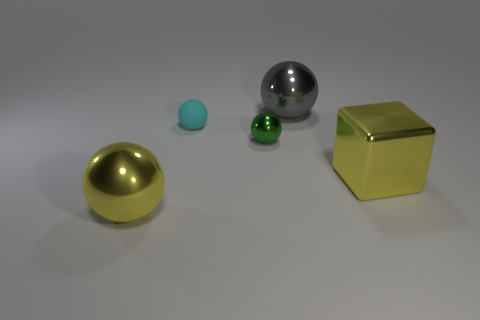Subtract all brown balls. Subtract all red cubes. How many balls are left? 4 Add 3 big gray rubber cylinders. How many objects exist? 8 Subtract all cubes. How many objects are left? 4 Add 2 yellow shiny balls. How many yellow shiny balls are left? 3 Add 3 small cyan rubber balls. How many small cyan rubber balls exist? 4 Subtract 0 purple spheres. How many objects are left? 5 Subtract all gray metallic spheres. Subtract all yellow shiny blocks. How many objects are left? 3 